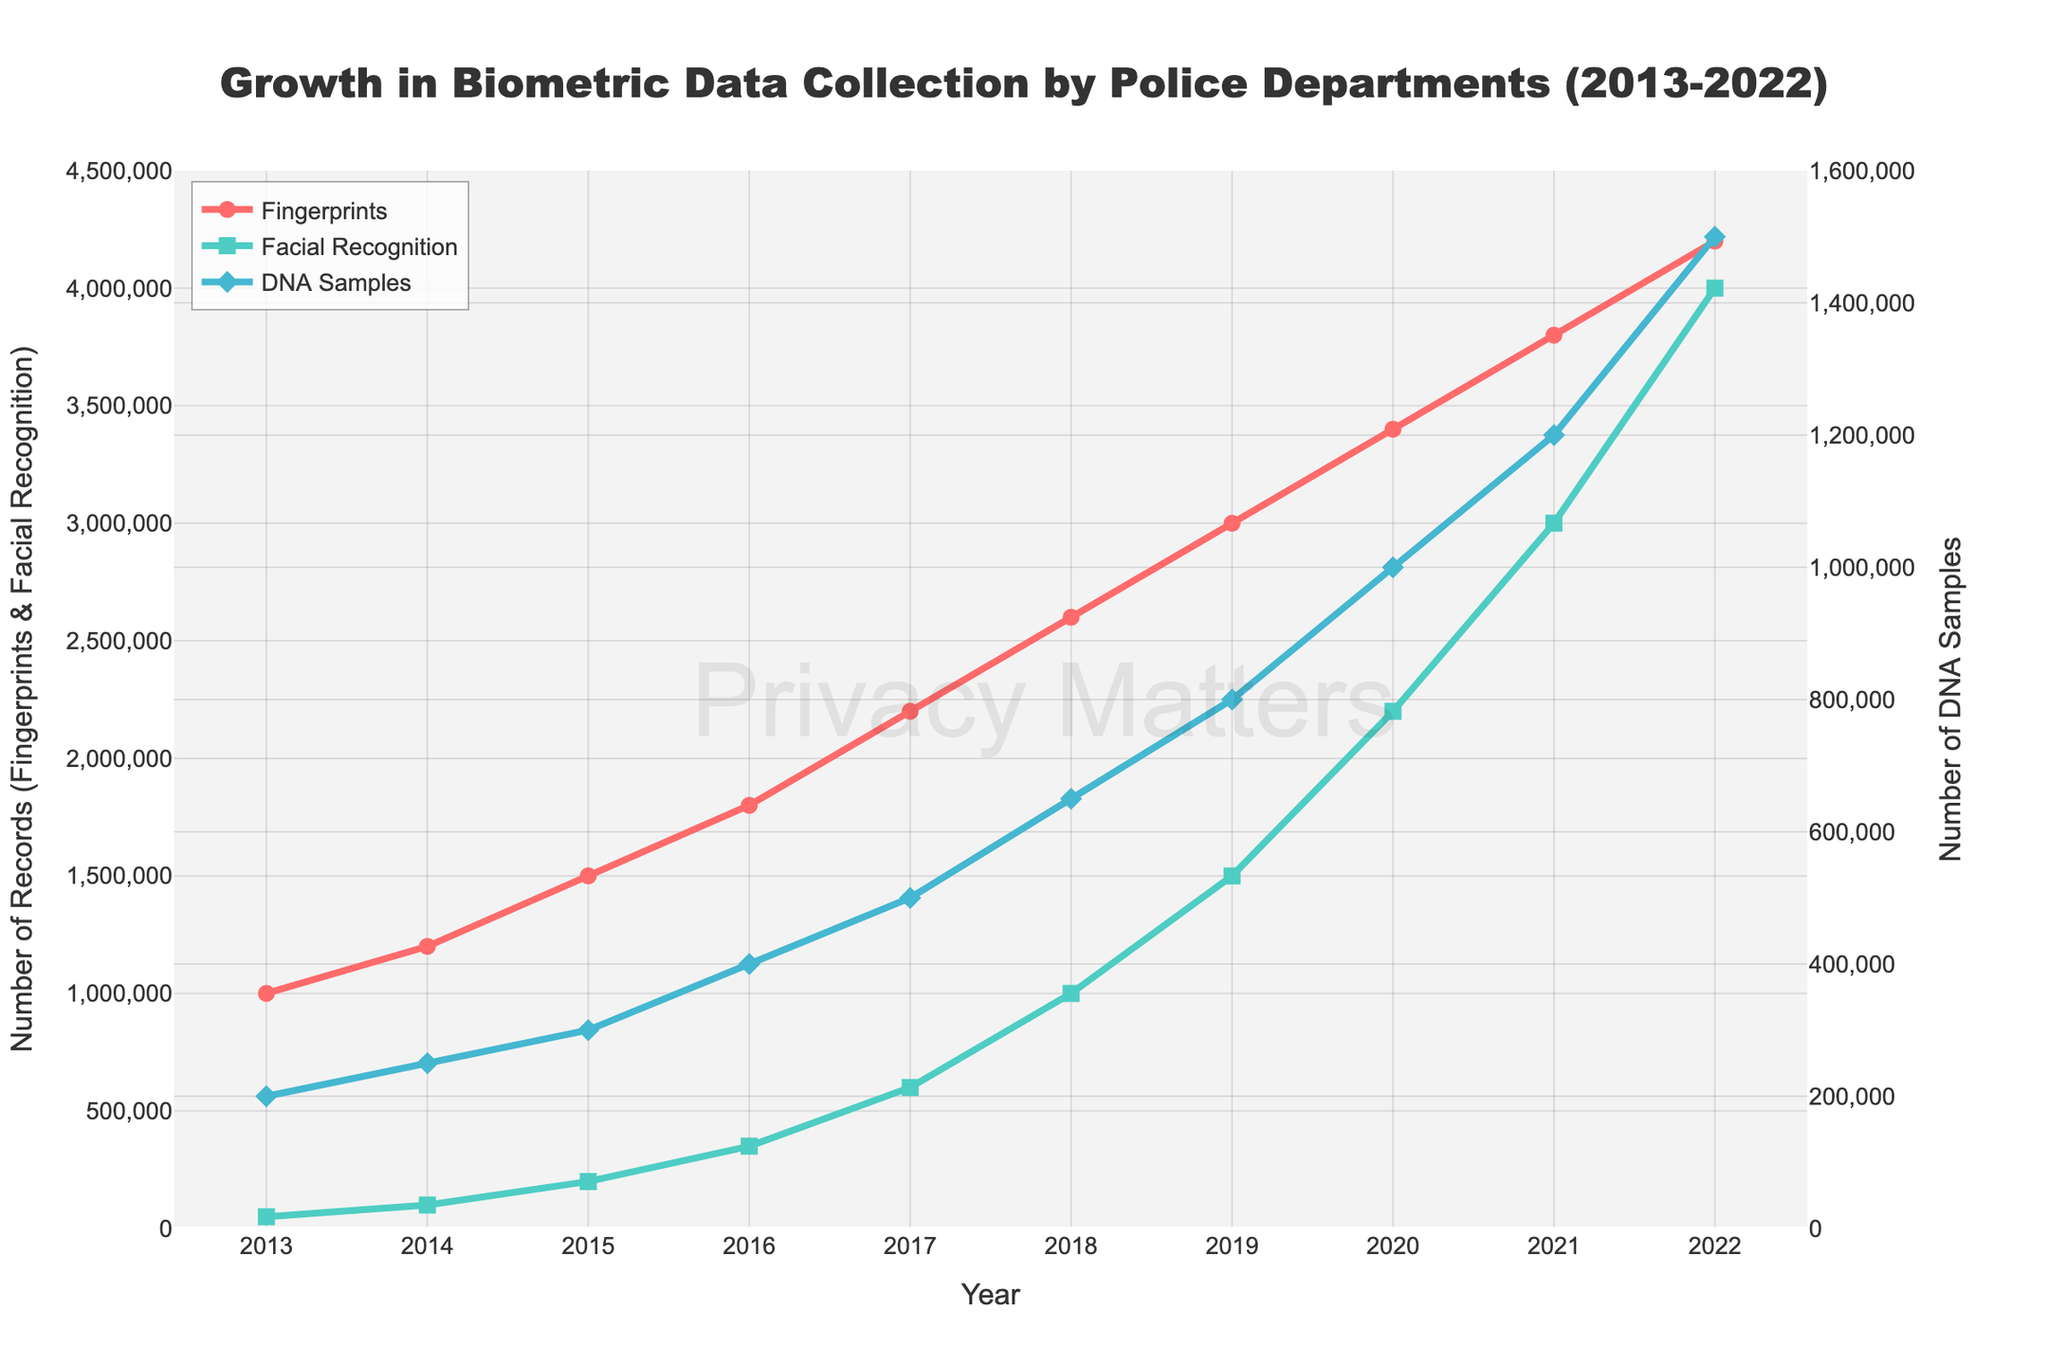What year saw the highest number of Facial Recognition records? The highest point on the line representing Facial Recognition data is at 2022.
Answer: 2022 How many more DNA Samples were collected in 2022 compared to 2013? From the chart, DNA Samples in 2022 is 1,500,000, and in 2013 it is 200,000. The difference is 1,500,000 - 200,000 = 1,300,000.
Answer: 1,300,000 Which biometric data type had the highest growth between 2013 to 2022? The chart shows growth visually by the steepness of the line. Facial Recognition increased from 50,000 in 2013 to 4,000,000 in 2022, an increase of 3,950,000. Fingerprints and DNA Samples did not grow as much numerically.
Answer: Facial Recognition Compare the increase in Fingerprints between 2013 and 2017 to the increase between 2018 and 2022. Which period saw a greater increase? From 2013 to 2017, Fingerprints grew from 1,000,000 to 2,200,000 (1,200,000 increase). Between 2018 and 2022, it grew from 2,600,000 to 4,200,000 (1,600,000 increase).
Answer: 2018 to 2022 What is the total number of Facial Recognition records collected from 2013 to 2022? Sum the data points for each year: 50,000 + 100,000 + 200,000 + 350,000 + 600,000 + 1,000,000 + 1,500,000 + 2,200,000 + 3,000,000 + 4,000,000 = 13,000,000.
Answer: 13,000,000 What is the average annual number of Fingerprints collected between 2013 and 2022? Sum the Fingerprints data points and divide by the number of years: (1,000,000 + 1,200,000 + 1,500,000 + 1,800,000 + 2,200,000 + 2,600,000 + 3,000,000 + 3,400,000 + 3,800,000 + 4,200,000) / 10 = 2,370,000.
Answer: 2,370,000 Which year had an equal number of DNA Samples to the total combined number of Fingerprints and Facial Recognition records in 2014? In 2014, Fingerprints were 1,200,000 and Facial Recognition was 100,000, totaling 1,300,000. In 2021, DNA Samples were also 1,200,000. No year had this exact total (some small discrepancy due to rounding).
Answer: None What color represents the Facial Recognition data in the chart? The line representing Facial Recognition is colored green.
Answer: Green Which biometric data type uses a diamond marker for the data points in the chart? The chart shows that DNA Samples use a diamond marker for their data points.
Answer: DNA Samples How does the trend of DNA Samples collection compare to Fingerprints from 2013 to 2022? The trend lines indicate that while both datasets show an upward trend, Fingerprints increase more steadily, while DNA Samples increase more rapidly in latter years.
Answer: Steeper in latter years 